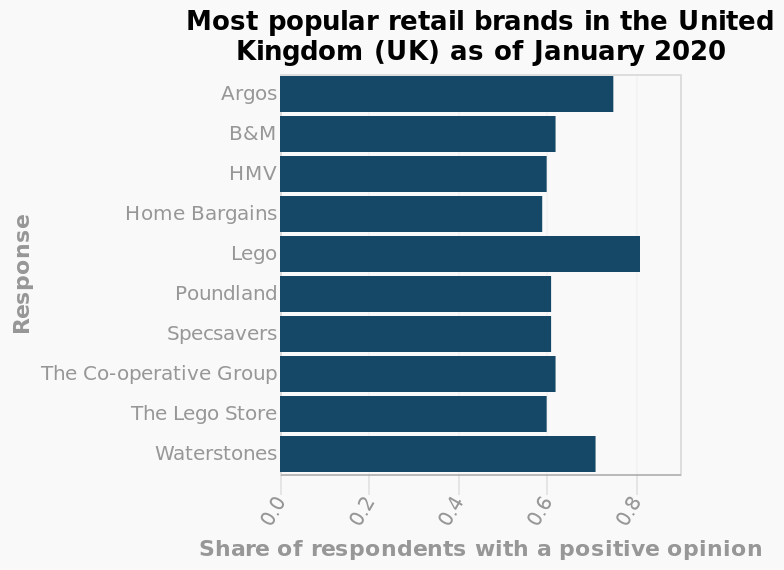<image>
please describe the details of the chart Here a is a bar chart named Most popular retail brands in the United Kingdom (UK) as of January 2020. The x-axis measures Share of respondents with a positive opinion while the y-axis measures Response. What does the y-axis measure in the bar chart?  The y-axis measures Response. What does the bar chart represent?  The bar chart represents the popularity of different retail brands in the United Kingdom (UK) as of January 2020. What is the title of the bar chart?  The title of the bar chart is "Most popular retail brands in the United Kingdom (UK) as of January 2020." Which companies have scores higher than 0.6?  Argos, Lego, and Waterstones. 